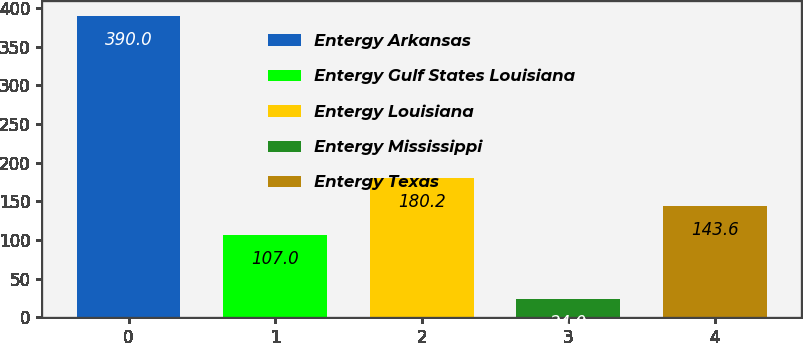<chart> <loc_0><loc_0><loc_500><loc_500><bar_chart><fcel>Entergy Arkansas<fcel>Entergy Gulf States Louisiana<fcel>Entergy Louisiana<fcel>Entergy Mississippi<fcel>Entergy Texas<nl><fcel>390<fcel>107<fcel>180.2<fcel>24<fcel>143.6<nl></chart> 